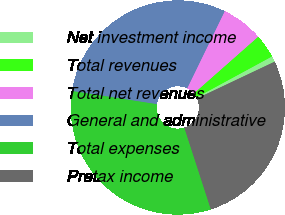Convert chart. <chart><loc_0><loc_0><loc_500><loc_500><pie_chart><fcel>Net investment income<fcel>Total revenues<fcel>Total net revenues<fcel>General and administrative<fcel>Total expenses<fcel>Pretax income<nl><fcel>0.88%<fcel>3.59%<fcel>6.29%<fcel>29.75%<fcel>32.45%<fcel>27.04%<nl></chart> 